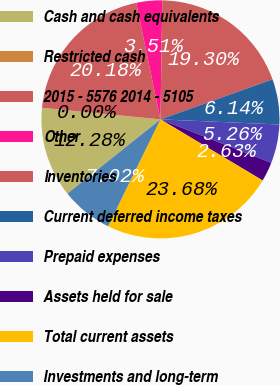<chart> <loc_0><loc_0><loc_500><loc_500><pie_chart><fcel>Cash and cash equivalents<fcel>Restricted cash<fcel>2015 - 5576 2014 - 5105<fcel>Other<fcel>Inventories<fcel>Current deferred income taxes<fcel>Prepaid expenses<fcel>Assets held for sale<fcel>Total current assets<fcel>Investments and long-term<nl><fcel>12.28%<fcel>0.0%<fcel>20.18%<fcel>3.51%<fcel>19.3%<fcel>6.14%<fcel>5.26%<fcel>2.63%<fcel>23.68%<fcel>7.02%<nl></chart> 